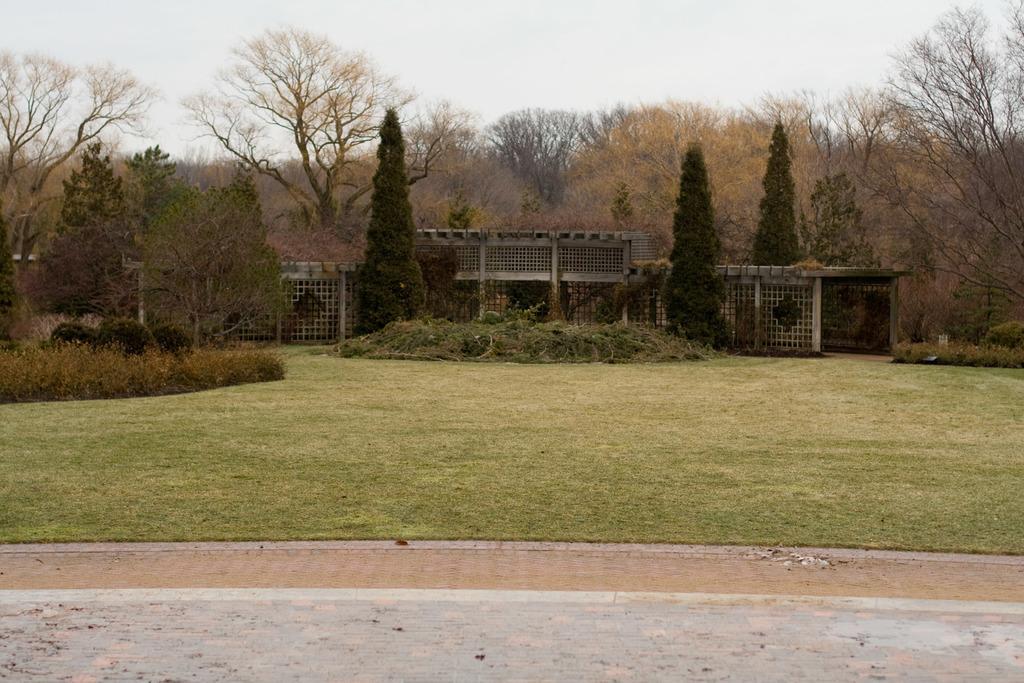How would you summarize this image in a sentence or two? In the foreground of the picture there are grass, pavement and dust. In the center of the picture there are trees, plants, building and waste. Sky is cloudy. 